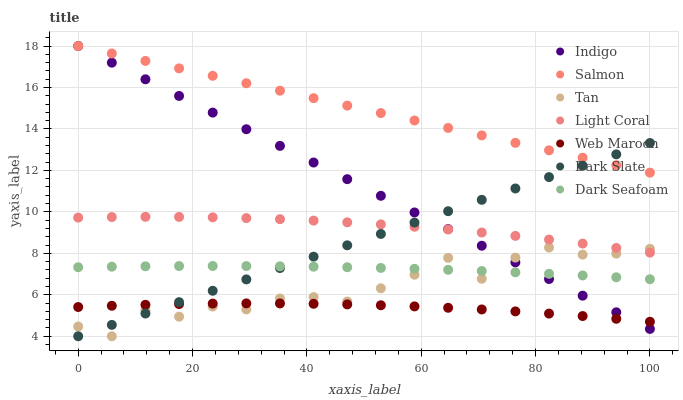Does Web Maroon have the minimum area under the curve?
Answer yes or no. Yes. Does Salmon have the maximum area under the curve?
Answer yes or no. Yes. Does Salmon have the minimum area under the curve?
Answer yes or no. No. Does Web Maroon have the maximum area under the curve?
Answer yes or no. No. Is Indigo the smoothest?
Answer yes or no. Yes. Is Tan the roughest?
Answer yes or no. Yes. Is Web Maroon the smoothest?
Answer yes or no. No. Is Web Maroon the roughest?
Answer yes or no. No. Does Dark Slate have the lowest value?
Answer yes or no. Yes. Does Web Maroon have the lowest value?
Answer yes or no. No. Does Salmon have the highest value?
Answer yes or no. Yes. Does Web Maroon have the highest value?
Answer yes or no. No. Is Web Maroon less than Salmon?
Answer yes or no. Yes. Is Salmon greater than Tan?
Answer yes or no. Yes. Does Light Coral intersect Tan?
Answer yes or no. Yes. Is Light Coral less than Tan?
Answer yes or no. No. Is Light Coral greater than Tan?
Answer yes or no. No. Does Web Maroon intersect Salmon?
Answer yes or no. No. 